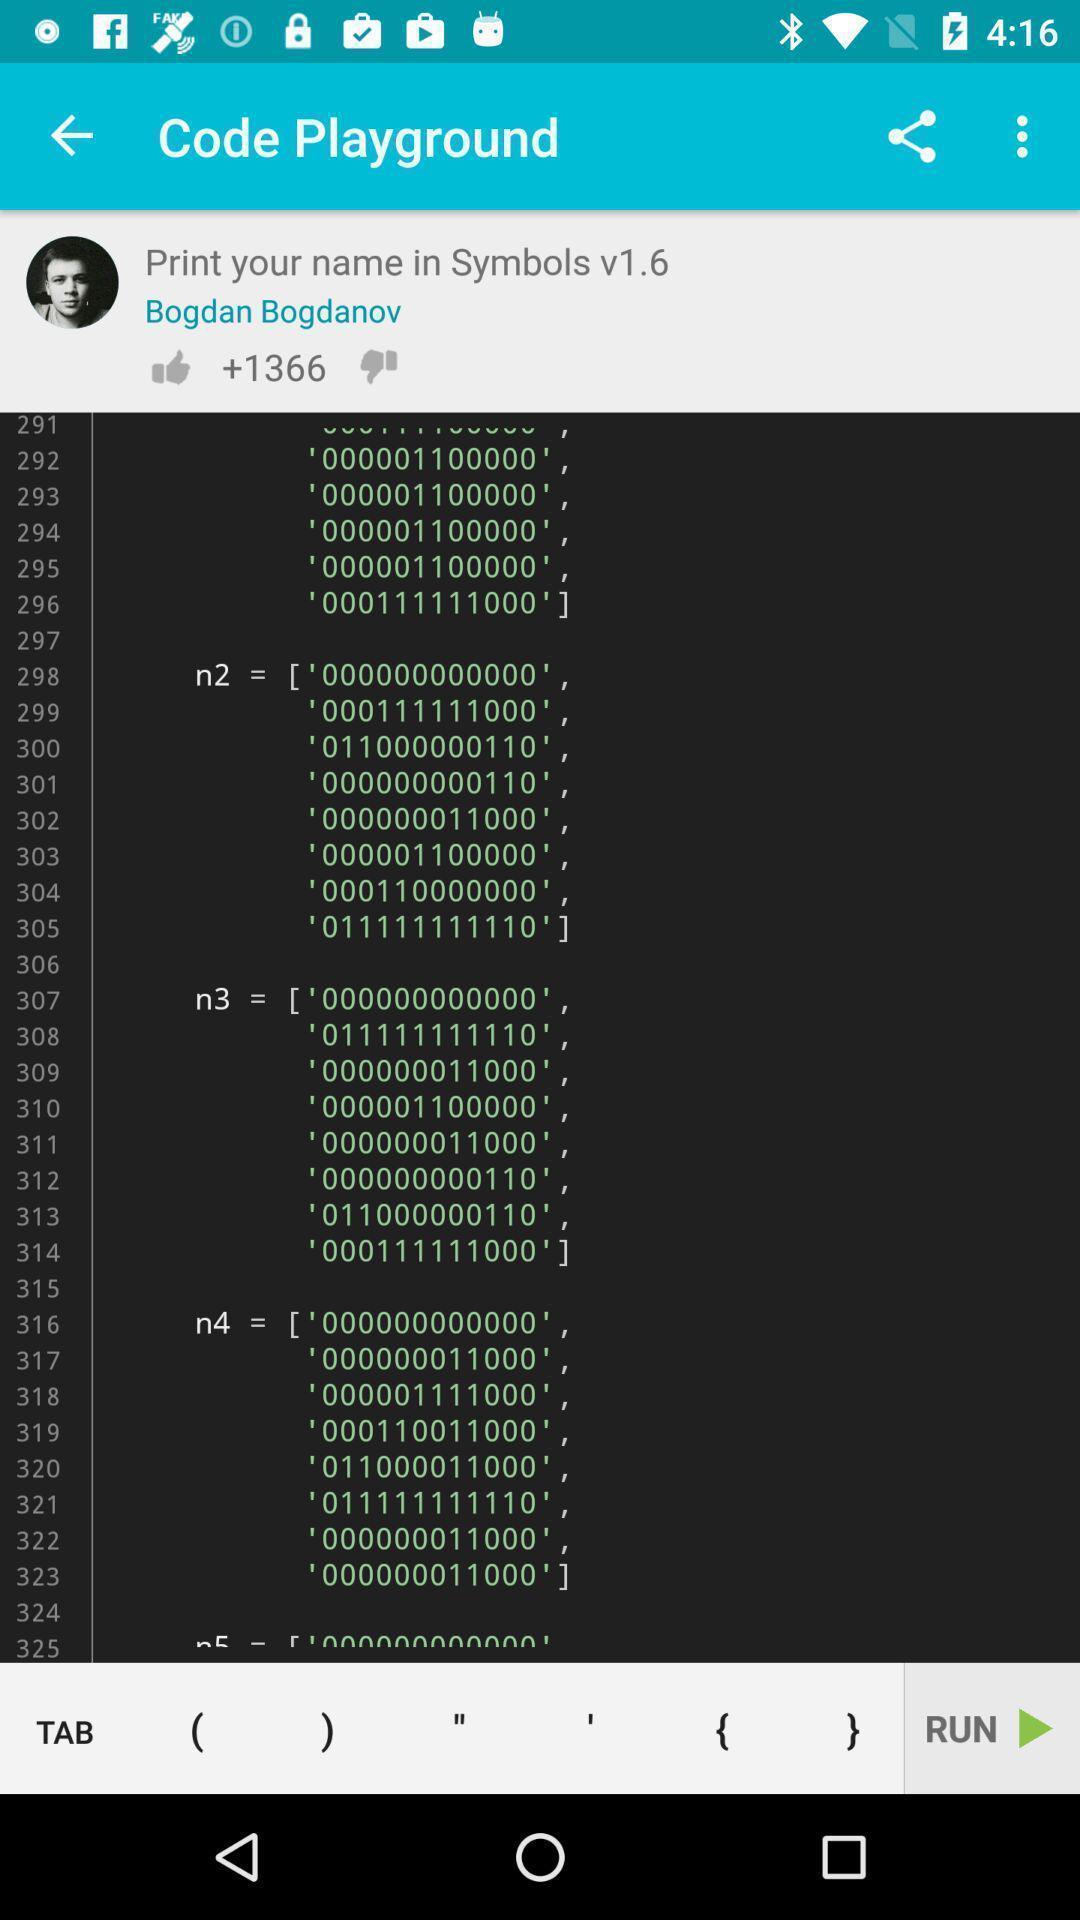Describe the content in this image. Page displays the numbers in the coding app. 